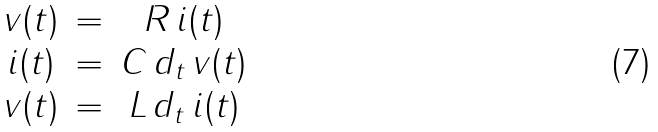<formula> <loc_0><loc_0><loc_500><loc_500>\begin{matrix} v ( t ) & = & R \, i ( t ) \\ i ( t ) & = & C \, d _ { t } \, v ( t ) \\ v ( t ) & = & L \, d _ { t } \, i ( t ) \end{matrix}</formula> 